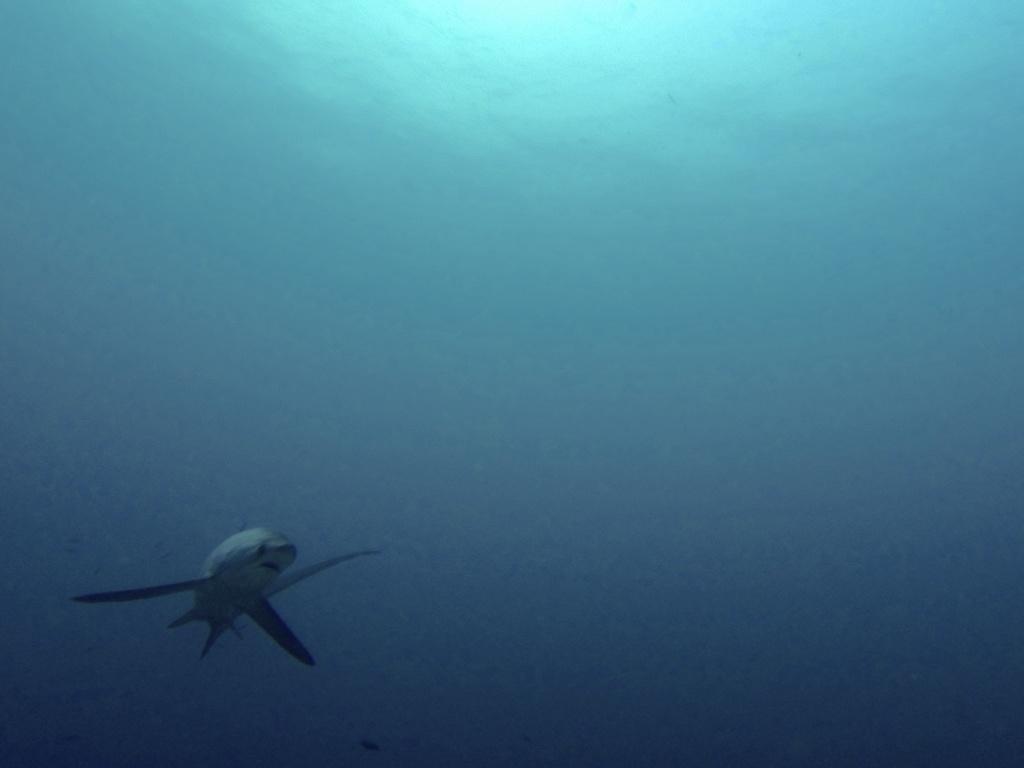Can you describe this image briefly? In this image there is a shark in the sea. 